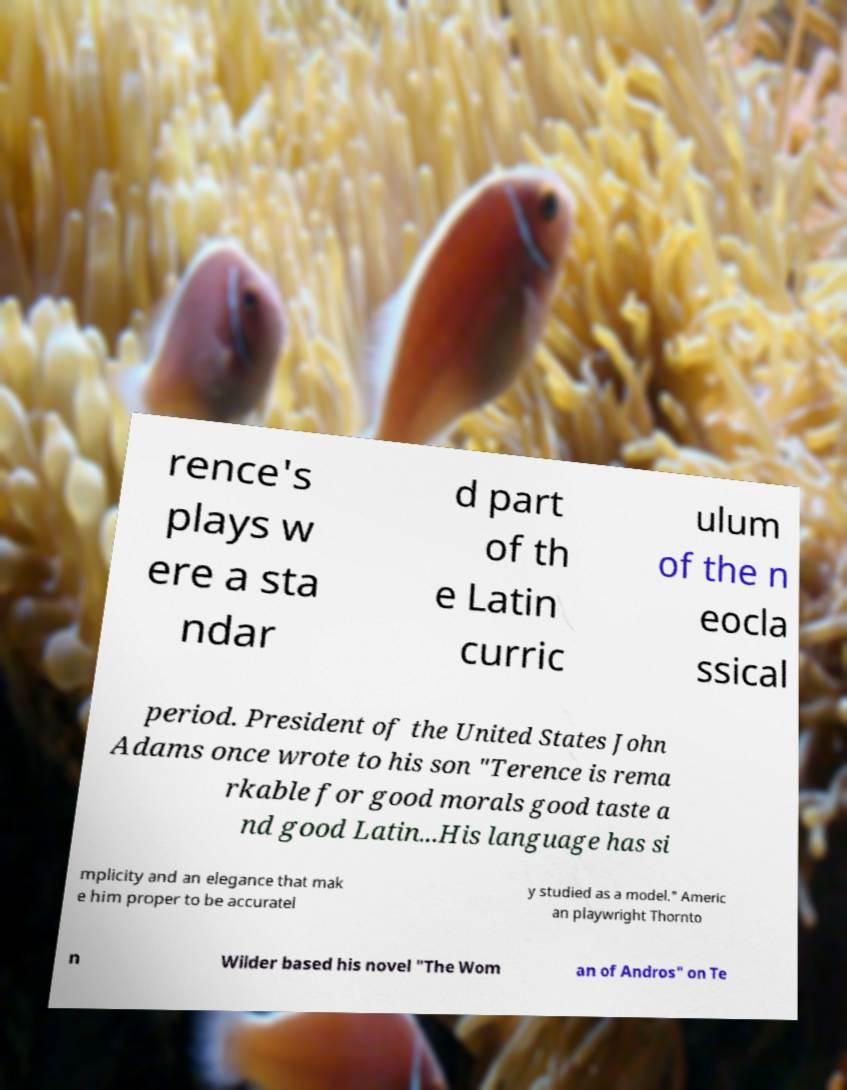Please read and relay the text visible in this image. What does it say? rence's plays w ere a sta ndar d part of th e Latin curric ulum of the n eocla ssical period. President of the United States John Adams once wrote to his son "Terence is rema rkable for good morals good taste a nd good Latin...His language has si mplicity and an elegance that mak e him proper to be accuratel y studied as a model." Americ an playwright Thornto n Wilder based his novel "The Wom an of Andros" on Te 